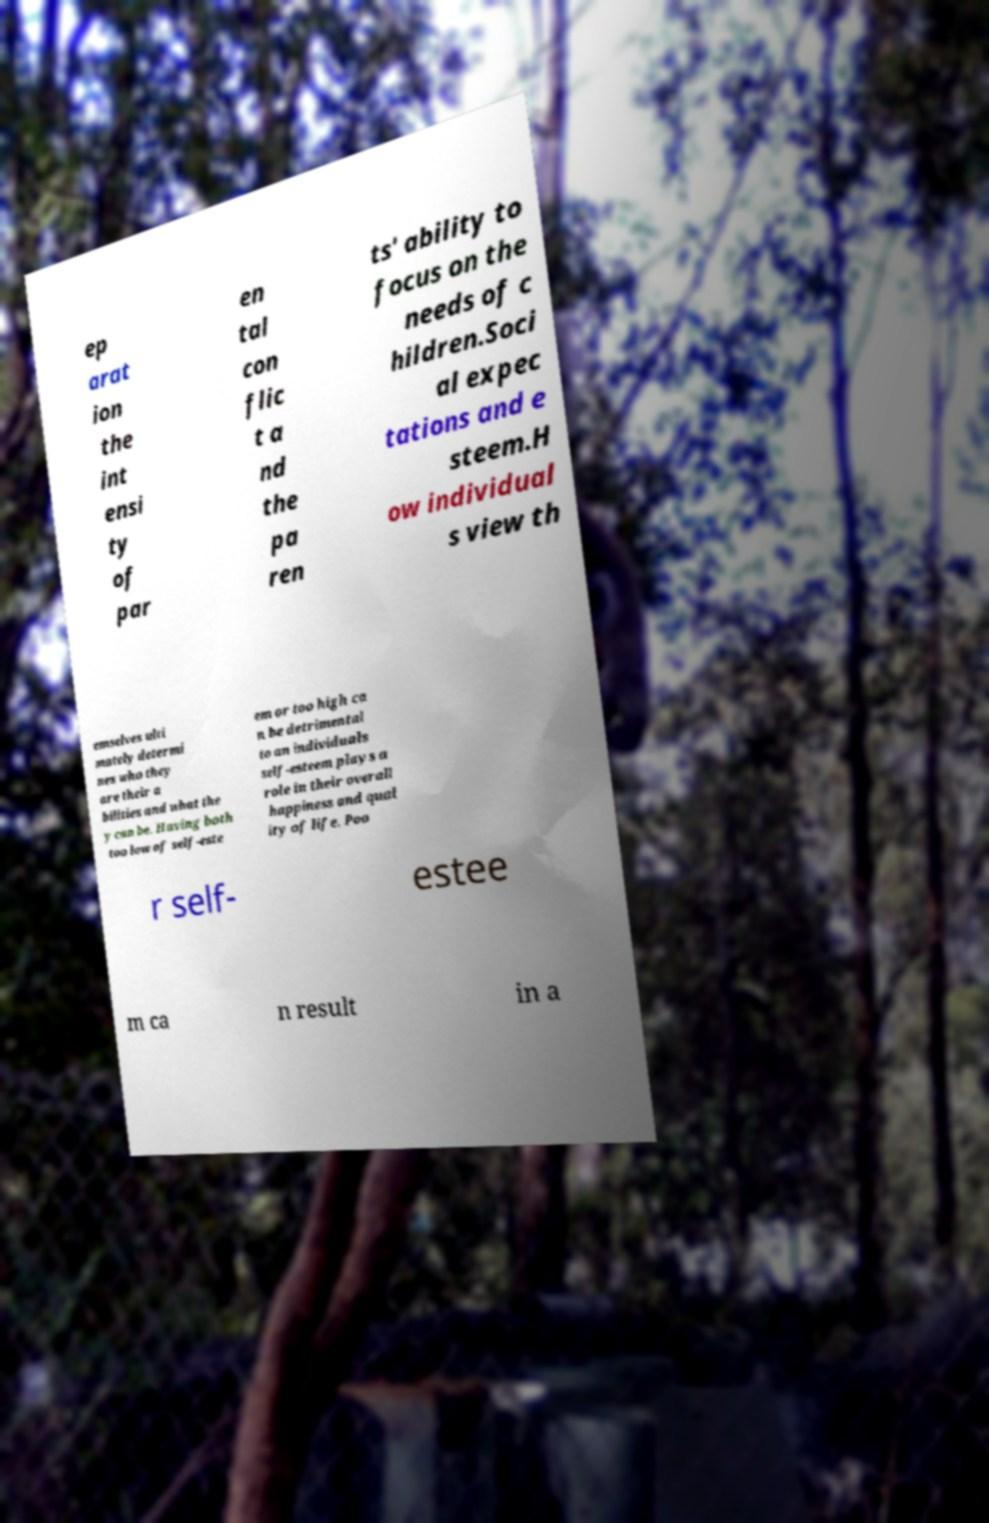I need the written content from this picture converted into text. Can you do that? ep arat ion the int ensi ty of par en tal con flic t a nd the pa ren ts' ability to focus on the needs of c hildren.Soci al expec tations and e steem.H ow individual s view th emselves ulti mately determi nes who they are their a bilities and what the y can be. Having both too low of self-este em or too high ca n be detrimental to an individuals self-esteem plays a role in their overall happiness and qual ity of life. Poo r self- estee m ca n result in a 